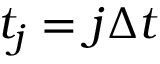<formula> <loc_0><loc_0><loc_500><loc_500>t _ { j } = j \Delta t</formula> 